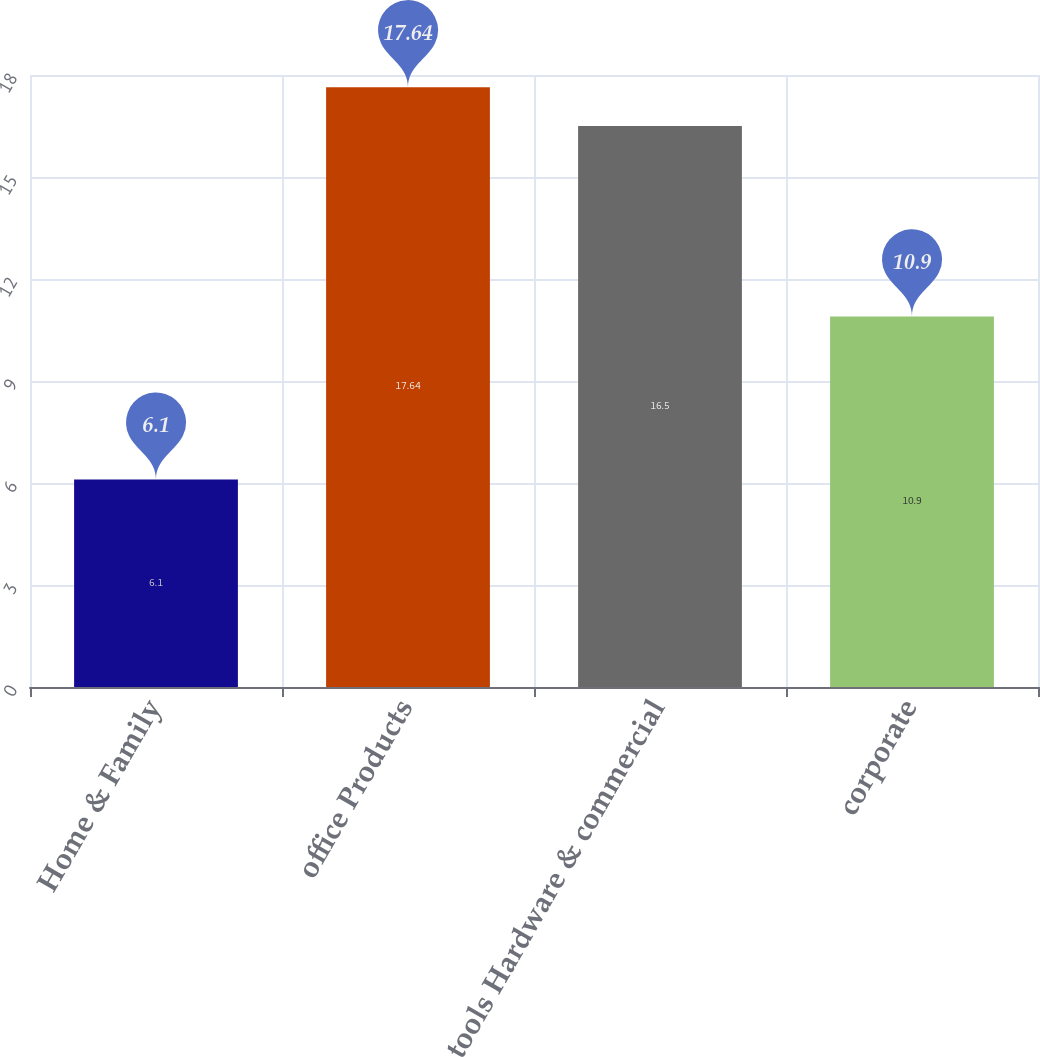Convert chart. <chart><loc_0><loc_0><loc_500><loc_500><bar_chart><fcel>Home & Family<fcel>office Products<fcel>tools Hardware & commercial<fcel>corporate<nl><fcel>6.1<fcel>17.64<fcel>16.5<fcel>10.9<nl></chart> 